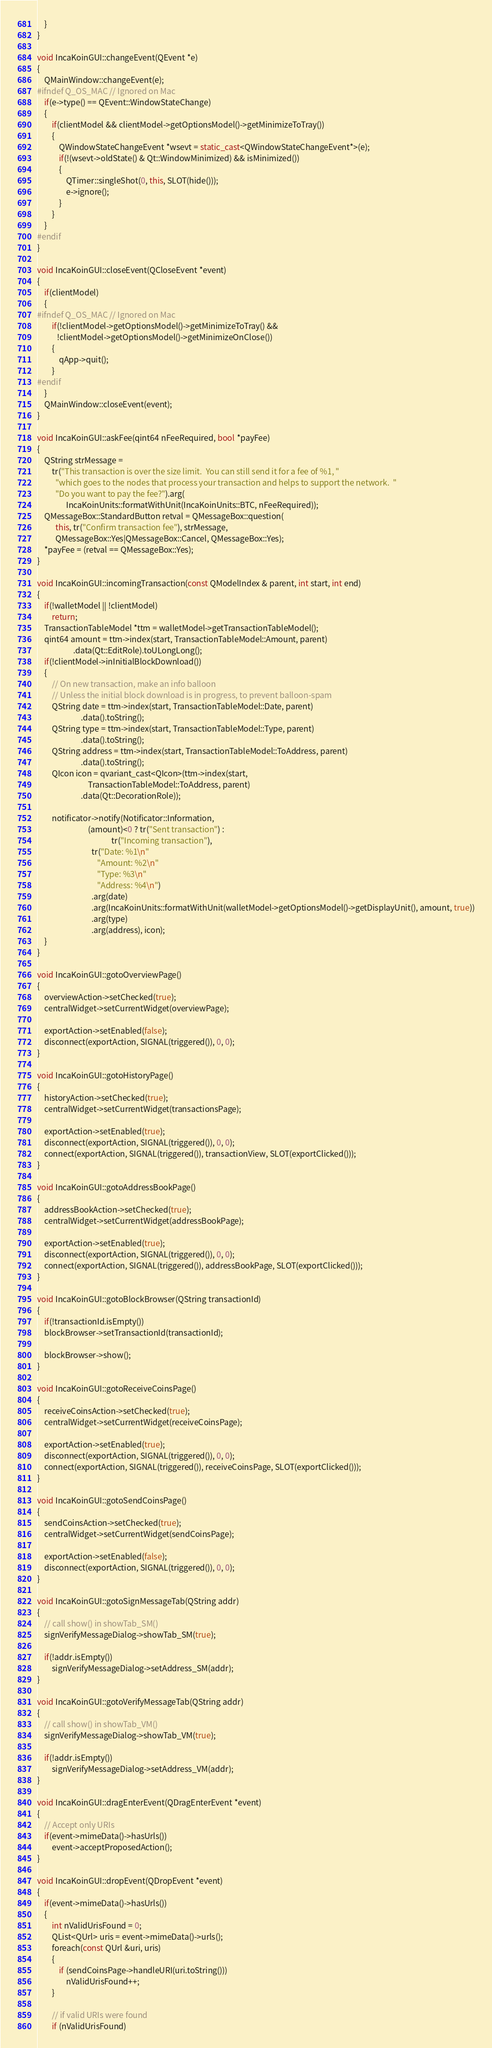Convert code to text. <code><loc_0><loc_0><loc_500><loc_500><_C++_>    }
}

void IncaKoinGUI::changeEvent(QEvent *e)
{
    QMainWindow::changeEvent(e);
#ifndef Q_OS_MAC // Ignored on Mac
    if(e->type() == QEvent::WindowStateChange)
    {
        if(clientModel && clientModel->getOptionsModel()->getMinimizeToTray())
        {
            QWindowStateChangeEvent *wsevt = static_cast<QWindowStateChangeEvent*>(e);
            if(!(wsevt->oldState() & Qt::WindowMinimized) && isMinimized())
            {
                QTimer::singleShot(0, this, SLOT(hide()));
                e->ignore();
            }
        }
    }
#endif
}

void IncaKoinGUI::closeEvent(QCloseEvent *event)
{
    if(clientModel)
    {
#ifndef Q_OS_MAC // Ignored on Mac
        if(!clientModel->getOptionsModel()->getMinimizeToTray() &&
           !clientModel->getOptionsModel()->getMinimizeOnClose())
        {
            qApp->quit();
        }
#endif
    }
    QMainWindow::closeEvent(event);
}

void IncaKoinGUI::askFee(qint64 nFeeRequired, bool *payFee)
{
    QString strMessage =
        tr("This transaction is over the size limit.  You can still send it for a fee of %1, "
          "which goes to the nodes that process your transaction and helps to support the network.  "
          "Do you want to pay the fee?").arg(
                IncaKoinUnits::formatWithUnit(IncaKoinUnits::BTC, nFeeRequired));
    QMessageBox::StandardButton retval = QMessageBox::question(
          this, tr("Confirm transaction fee"), strMessage,
          QMessageBox::Yes|QMessageBox::Cancel, QMessageBox::Yes);
    *payFee = (retval == QMessageBox::Yes);
}

void IncaKoinGUI::incomingTransaction(const QModelIndex & parent, int start, int end)
{
    if(!walletModel || !clientModel)
        return;
    TransactionTableModel *ttm = walletModel->getTransactionTableModel();
    qint64 amount = ttm->index(start, TransactionTableModel::Amount, parent)
                    .data(Qt::EditRole).toULongLong();
    if(!clientModel->inInitialBlockDownload())
    {
        // On new transaction, make an info balloon
        // Unless the initial block download is in progress, to prevent balloon-spam
        QString date = ttm->index(start, TransactionTableModel::Date, parent)
                        .data().toString();
        QString type = ttm->index(start, TransactionTableModel::Type, parent)
                        .data().toString();
        QString address = ttm->index(start, TransactionTableModel::ToAddress, parent)
                        .data().toString();
        QIcon icon = qvariant_cast<QIcon>(ttm->index(start,
                            TransactionTableModel::ToAddress, parent)
                        .data(Qt::DecorationRole));

        notificator->notify(Notificator::Information,
                            (amount)<0 ? tr("Sent transaction") :
                                         tr("Incoming transaction"),
                              tr("Date: %1\n"
                                 "Amount: %2\n"
                                 "Type: %3\n"
                                 "Address: %4\n")
                              .arg(date)
                              .arg(IncaKoinUnits::formatWithUnit(walletModel->getOptionsModel()->getDisplayUnit(), amount, true))
                              .arg(type)
                              .arg(address), icon);
    }
}

void IncaKoinGUI::gotoOverviewPage()
{
    overviewAction->setChecked(true);
    centralWidget->setCurrentWidget(overviewPage);

    exportAction->setEnabled(false);
    disconnect(exportAction, SIGNAL(triggered()), 0, 0);
}

void IncaKoinGUI::gotoHistoryPage()
{
    historyAction->setChecked(true);
    centralWidget->setCurrentWidget(transactionsPage);

    exportAction->setEnabled(true);
    disconnect(exportAction, SIGNAL(triggered()), 0, 0);
    connect(exportAction, SIGNAL(triggered()), transactionView, SLOT(exportClicked()));
}

void IncaKoinGUI::gotoAddressBookPage()
{
    addressBookAction->setChecked(true);
    centralWidget->setCurrentWidget(addressBookPage);

    exportAction->setEnabled(true);
    disconnect(exportAction, SIGNAL(triggered()), 0, 0);
    connect(exportAction, SIGNAL(triggered()), addressBookPage, SLOT(exportClicked()));
}

void IncaKoinGUI::gotoBlockBrowser(QString transactionId)
{
    if(!transactionId.isEmpty())
    blockBrowser->setTransactionId(transactionId);
    
    blockBrowser->show();
}

void IncaKoinGUI::gotoReceiveCoinsPage()
{
    receiveCoinsAction->setChecked(true);
    centralWidget->setCurrentWidget(receiveCoinsPage);

    exportAction->setEnabled(true);
    disconnect(exportAction, SIGNAL(triggered()), 0, 0);
    connect(exportAction, SIGNAL(triggered()), receiveCoinsPage, SLOT(exportClicked()));
}

void IncaKoinGUI::gotoSendCoinsPage()
{
    sendCoinsAction->setChecked(true);
    centralWidget->setCurrentWidget(sendCoinsPage);

    exportAction->setEnabled(false);
    disconnect(exportAction, SIGNAL(triggered()), 0, 0);
}

void IncaKoinGUI::gotoSignMessageTab(QString addr)
{
    // call show() in showTab_SM()
    signVerifyMessageDialog->showTab_SM(true);

    if(!addr.isEmpty())
        signVerifyMessageDialog->setAddress_SM(addr);
}

void IncaKoinGUI::gotoVerifyMessageTab(QString addr)
{
    // call show() in showTab_VM()
    signVerifyMessageDialog->showTab_VM(true);

    if(!addr.isEmpty())
        signVerifyMessageDialog->setAddress_VM(addr);
}

void IncaKoinGUI::dragEnterEvent(QDragEnterEvent *event)
{
    // Accept only URIs
    if(event->mimeData()->hasUrls())
        event->acceptProposedAction();
}

void IncaKoinGUI::dropEvent(QDropEvent *event)
{
    if(event->mimeData()->hasUrls())
    {
        int nValidUrisFound = 0;
        QList<QUrl> uris = event->mimeData()->urls();
        foreach(const QUrl &uri, uris)
        {
            if (sendCoinsPage->handleURI(uri.toString()))
                nValidUrisFound++;
        }

        // if valid URIs were found
        if (nValidUrisFound)</code> 